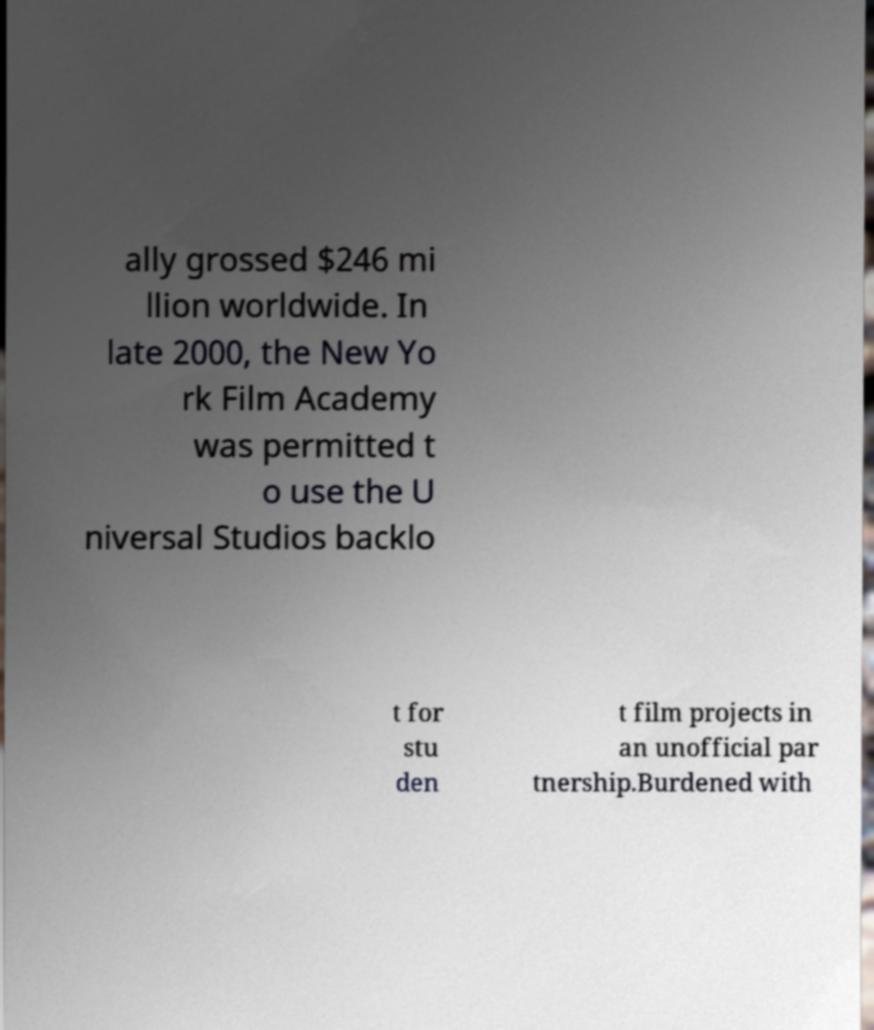What messages or text are displayed in this image? I need them in a readable, typed format. ally grossed $246 mi llion worldwide. In late 2000, the New Yo rk Film Academy was permitted t o use the U niversal Studios backlo t for stu den t film projects in an unofficial par tnership.Burdened with 